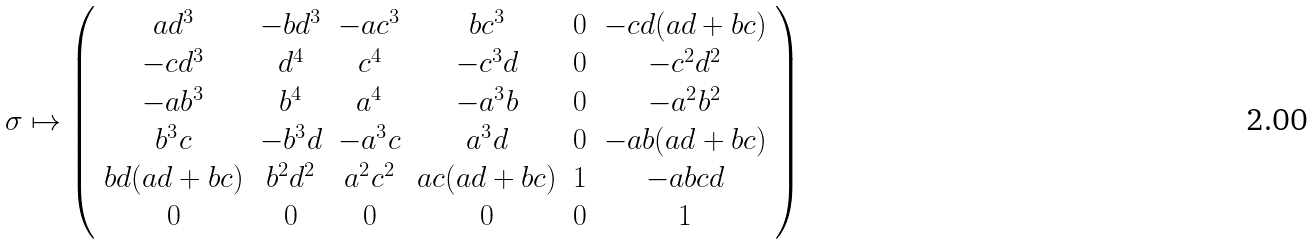Convert formula to latex. <formula><loc_0><loc_0><loc_500><loc_500>\sigma \mapsto \left ( \begin{array} { c c c c c c } a d ^ { 3 } & - b d ^ { 3 } & - a c ^ { 3 } & b c ^ { 3 } & 0 & - c d ( a d + b c ) \\ - c d ^ { 3 } & d ^ { 4 } & c ^ { 4 } & - c ^ { 3 } d & 0 & - c ^ { 2 } d ^ { 2 } \\ - a b ^ { 3 } & b ^ { 4 } & a ^ { 4 } & - a ^ { 3 } b & 0 & - a ^ { 2 } b ^ { 2 } \\ b ^ { 3 } c & - b ^ { 3 } d & - a ^ { 3 } c & a ^ { 3 } d & 0 & - a b ( a d + b c ) \\ b d ( a d + b c ) & b ^ { 2 } d ^ { 2 } & a ^ { 2 } c ^ { 2 } & a c ( a d + b c ) & 1 & - a b c d \\ 0 & 0 & 0 & 0 & 0 & 1 \end{array} \right )</formula> 